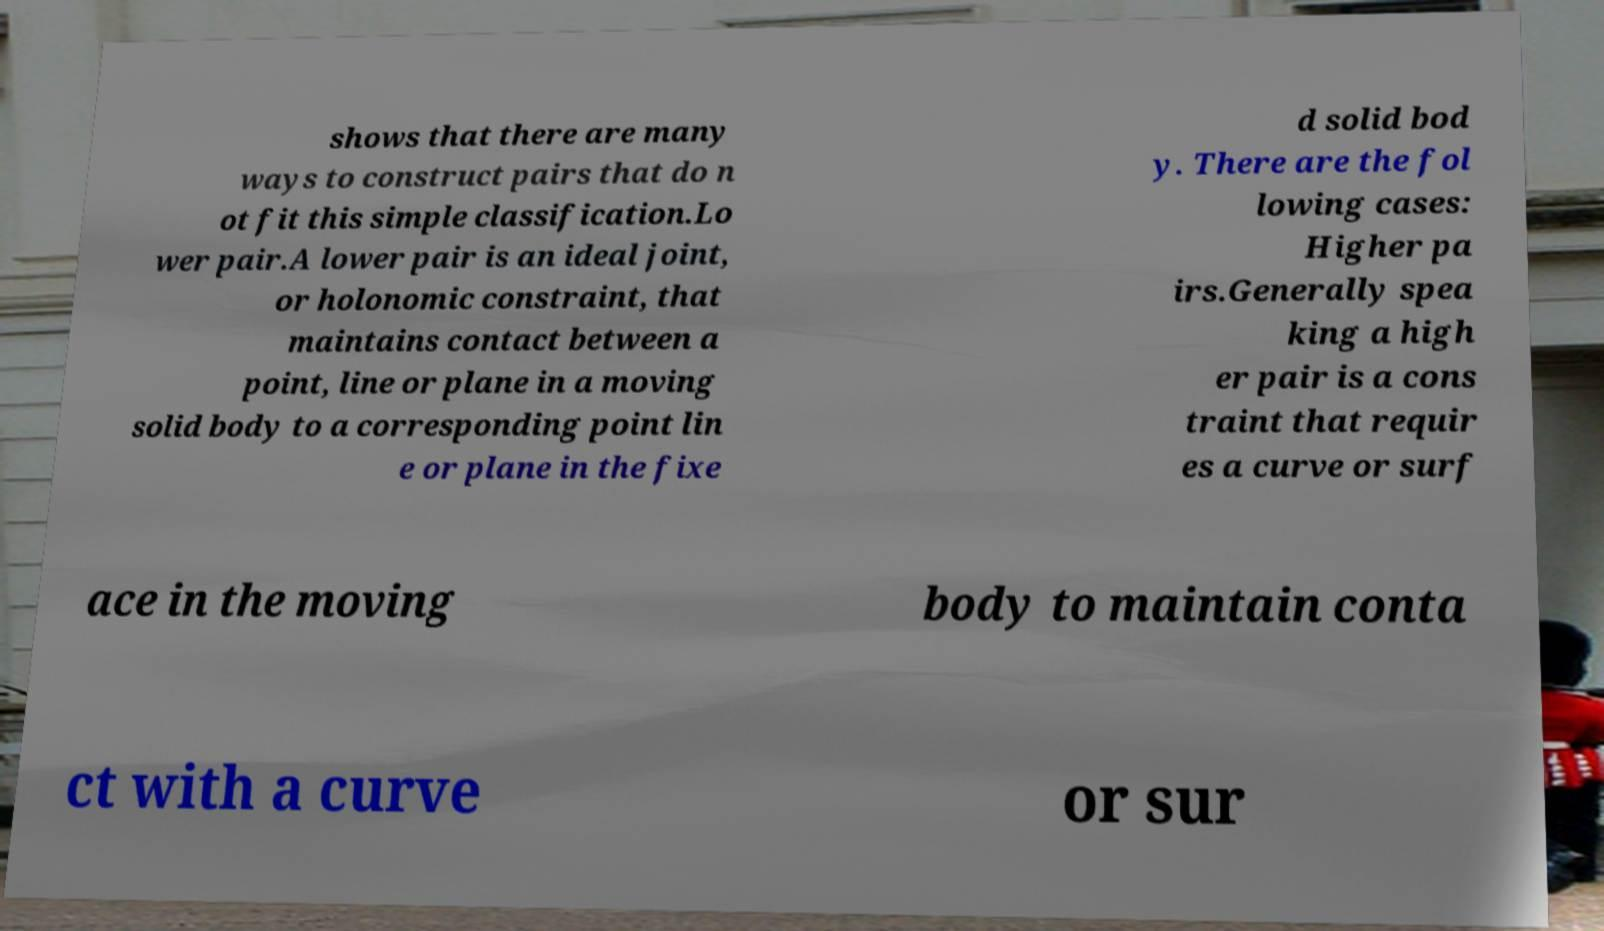Can you accurately transcribe the text from the provided image for me? shows that there are many ways to construct pairs that do n ot fit this simple classification.Lo wer pair.A lower pair is an ideal joint, or holonomic constraint, that maintains contact between a point, line or plane in a moving solid body to a corresponding point lin e or plane in the fixe d solid bod y. There are the fol lowing cases: Higher pa irs.Generally spea king a high er pair is a cons traint that requir es a curve or surf ace in the moving body to maintain conta ct with a curve or sur 